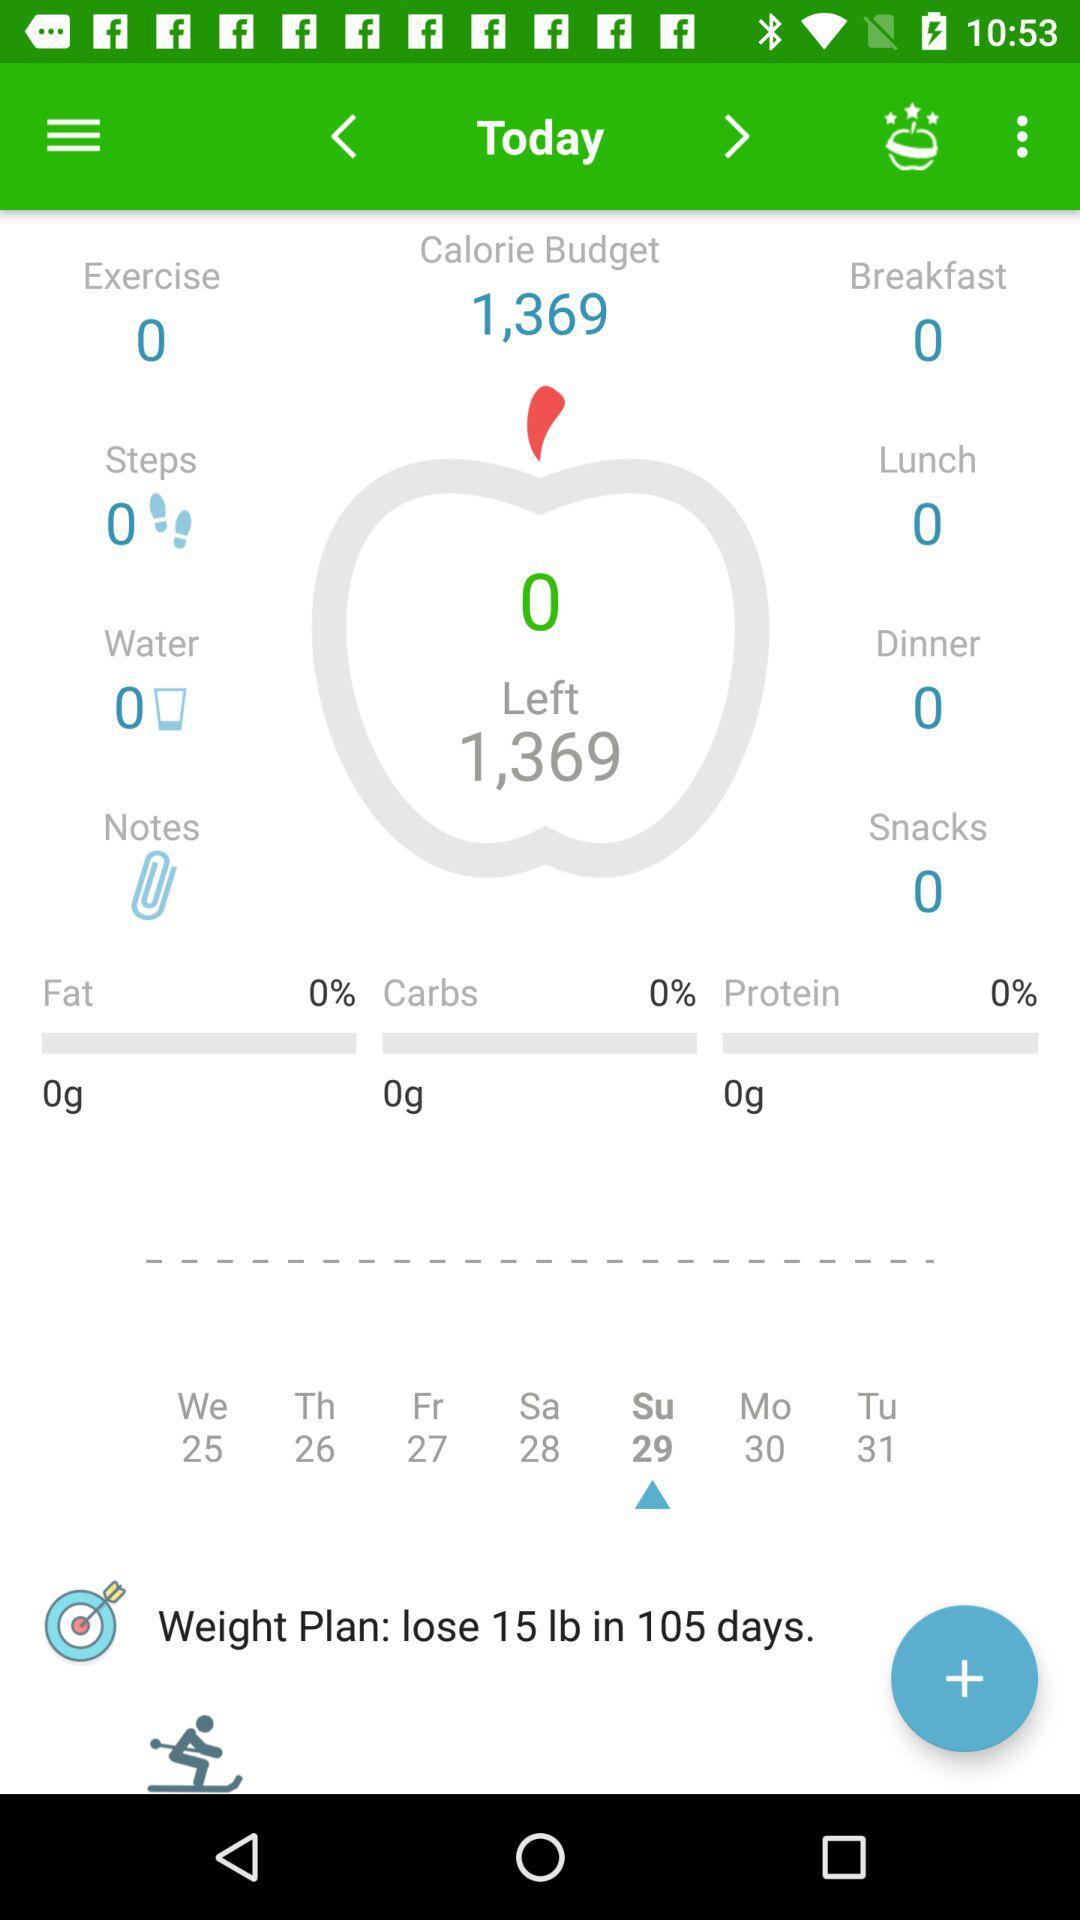What is the total number of calories in the budget? The total number of calories in the budget is 1,369. 